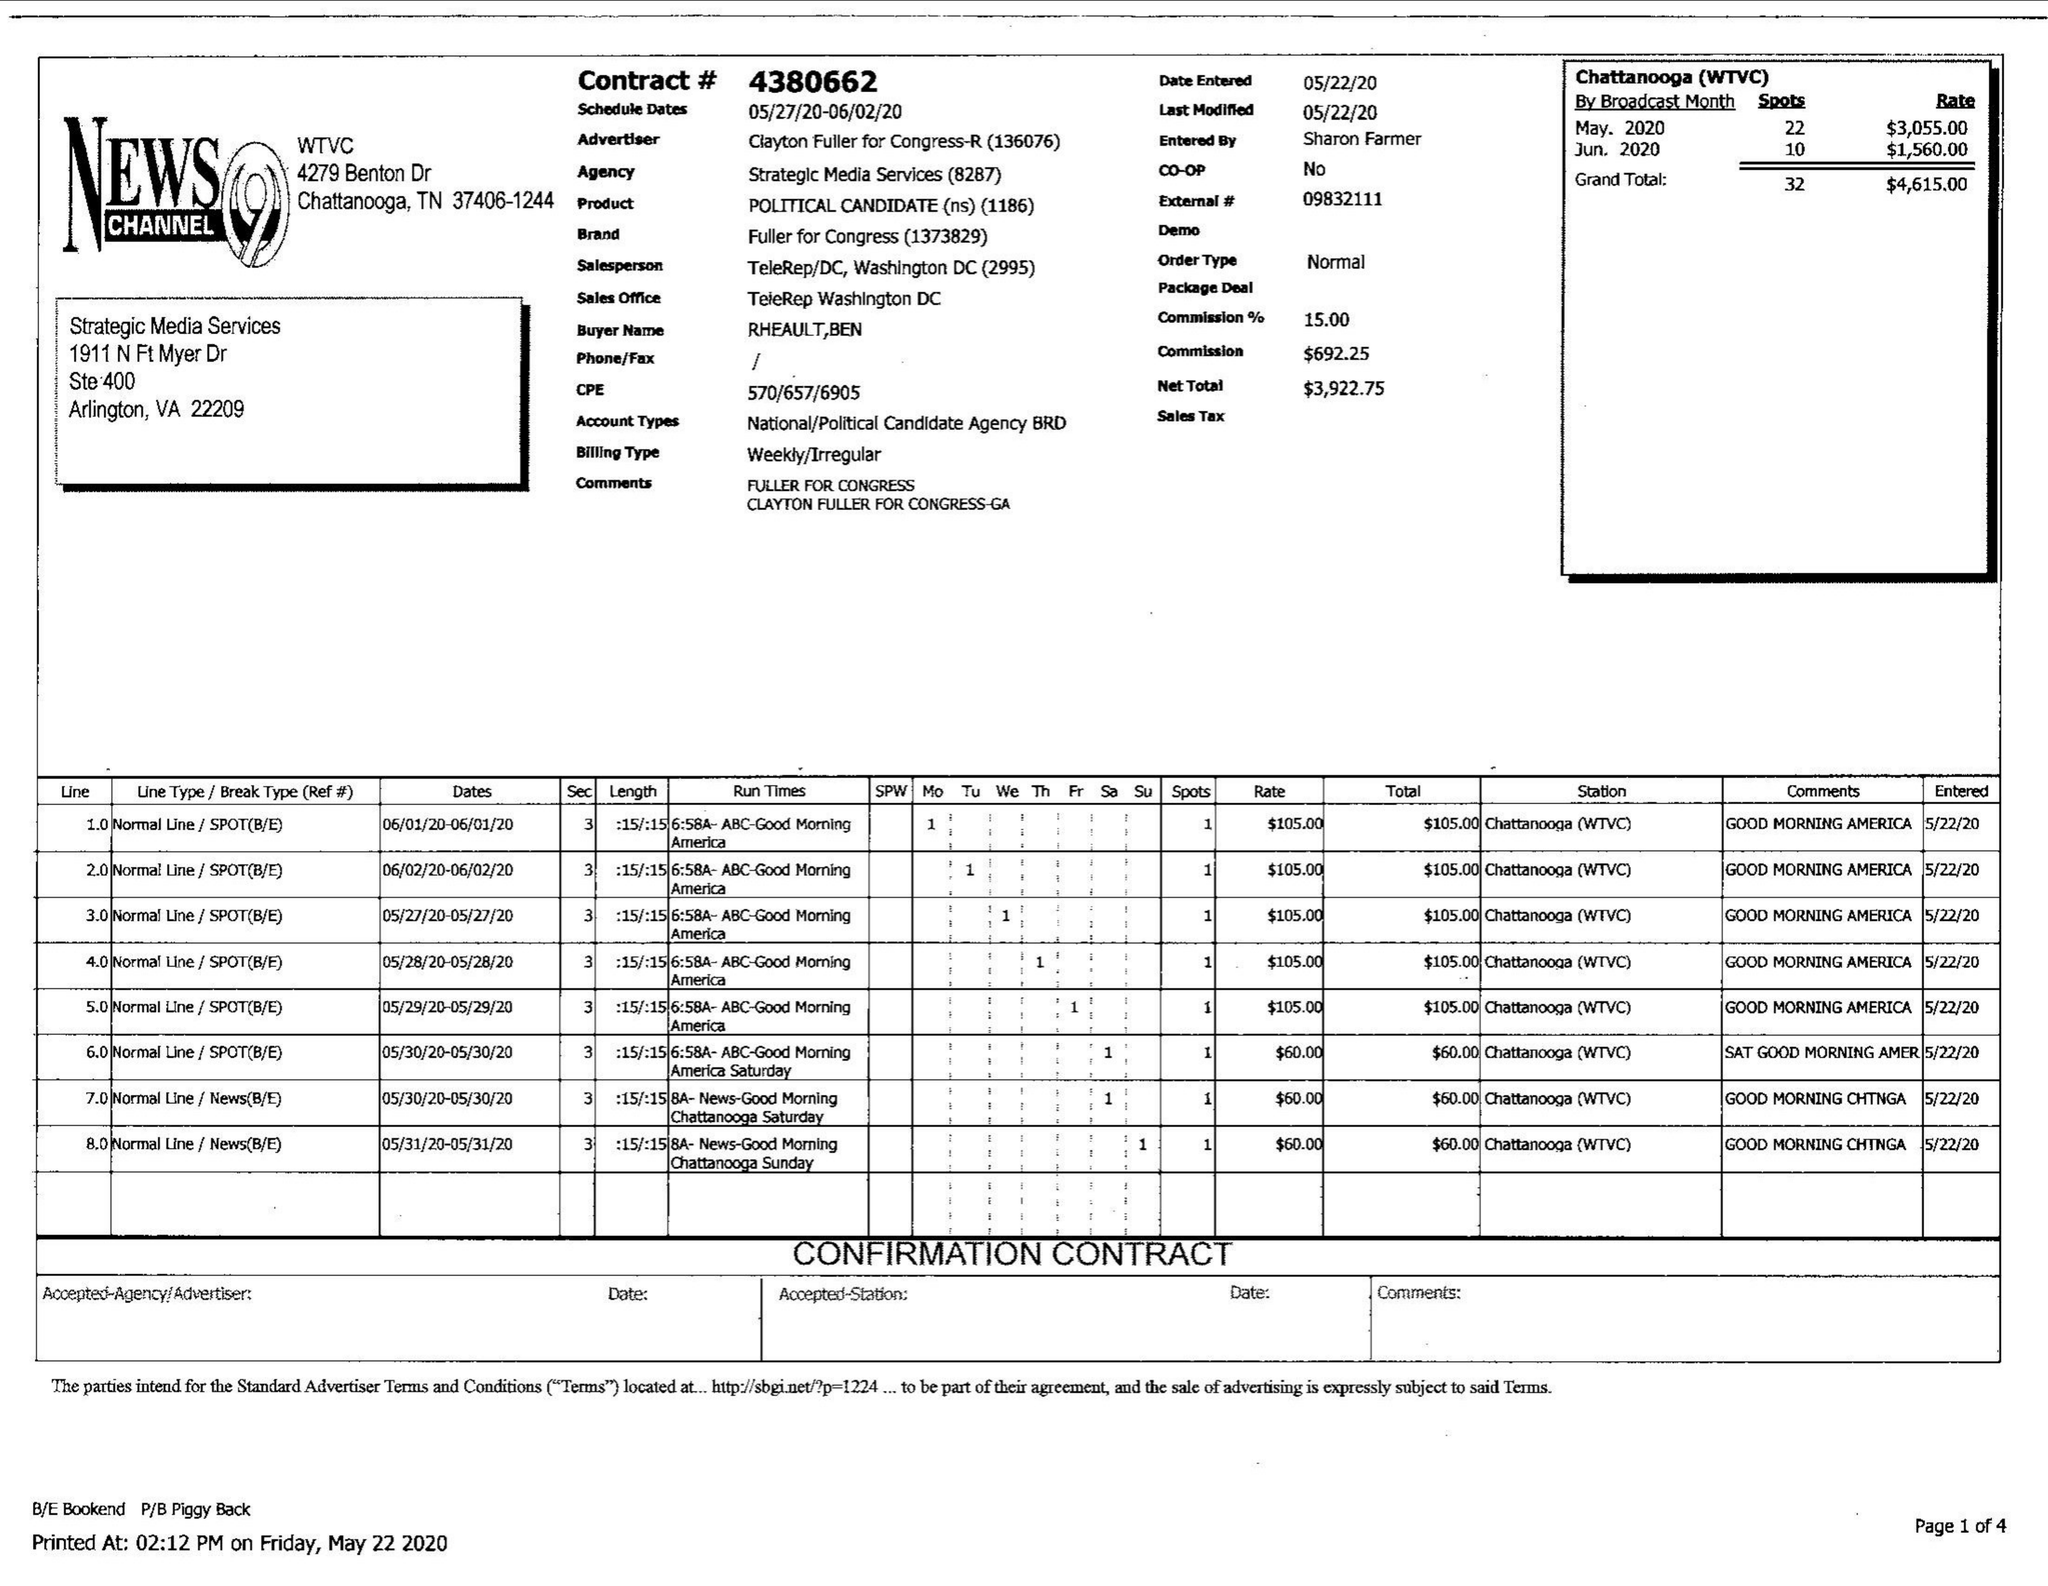What is the value for the gross_amount?
Answer the question using a single word or phrase. 4615.00 